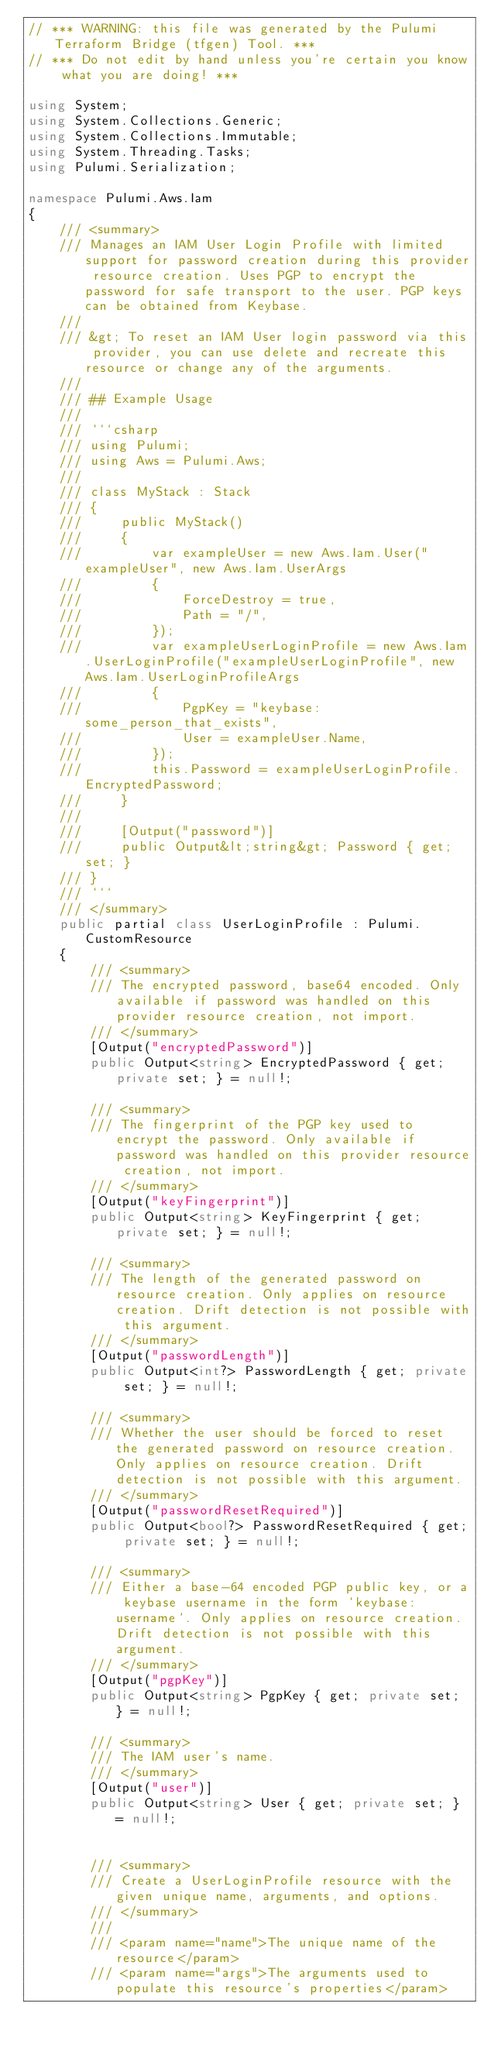<code> <loc_0><loc_0><loc_500><loc_500><_C#_>// *** WARNING: this file was generated by the Pulumi Terraform Bridge (tfgen) Tool. ***
// *** Do not edit by hand unless you're certain you know what you are doing! ***

using System;
using System.Collections.Generic;
using System.Collections.Immutable;
using System.Threading.Tasks;
using Pulumi.Serialization;

namespace Pulumi.Aws.Iam
{
    /// <summary>
    /// Manages an IAM User Login Profile with limited support for password creation during this provider resource creation. Uses PGP to encrypt the password for safe transport to the user. PGP keys can be obtained from Keybase.
    /// 
    /// &gt; To reset an IAM User login password via this provider, you can use delete and recreate this resource or change any of the arguments.
    /// 
    /// ## Example Usage
    /// 
    /// ```csharp
    /// using Pulumi;
    /// using Aws = Pulumi.Aws;
    /// 
    /// class MyStack : Stack
    /// {
    ///     public MyStack()
    ///     {
    ///         var exampleUser = new Aws.Iam.User("exampleUser", new Aws.Iam.UserArgs
    ///         {
    ///             ForceDestroy = true,
    ///             Path = "/",
    ///         });
    ///         var exampleUserLoginProfile = new Aws.Iam.UserLoginProfile("exampleUserLoginProfile", new Aws.Iam.UserLoginProfileArgs
    ///         {
    ///             PgpKey = "keybase:some_person_that_exists",
    ///             User = exampleUser.Name,
    ///         });
    ///         this.Password = exampleUserLoginProfile.EncryptedPassword;
    ///     }
    /// 
    ///     [Output("password")]
    ///     public Output&lt;string&gt; Password { get; set; }
    /// }
    /// ```
    /// </summary>
    public partial class UserLoginProfile : Pulumi.CustomResource
    {
        /// <summary>
        /// The encrypted password, base64 encoded. Only available if password was handled on this provider resource creation, not import.
        /// </summary>
        [Output("encryptedPassword")]
        public Output<string> EncryptedPassword { get; private set; } = null!;

        /// <summary>
        /// The fingerprint of the PGP key used to encrypt the password. Only available if password was handled on this provider resource creation, not import.
        /// </summary>
        [Output("keyFingerprint")]
        public Output<string> KeyFingerprint { get; private set; } = null!;

        /// <summary>
        /// The length of the generated password on resource creation. Only applies on resource creation. Drift detection is not possible with this argument.
        /// </summary>
        [Output("passwordLength")]
        public Output<int?> PasswordLength { get; private set; } = null!;

        /// <summary>
        /// Whether the user should be forced to reset the generated password on resource creation. Only applies on resource creation. Drift detection is not possible with this argument.
        /// </summary>
        [Output("passwordResetRequired")]
        public Output<bool?> PasswordResetRequired { get; private set; } = null!;

        /// <summary>
        /// Either a base-64 encoded PGP public key, or a keybase username in the form `keybase:username`. Only applies on resource creation. Drift detection is not possible with this argument.
        /// </summary>
        [Output("pgpKey")]
        public Output<string> PgpKey { get; private set; } = null!;

        /// <summary>
        /// The IAM user's name.
        /// </summary>
        [Output("user")]
        public Output<string> User { get; private set; } = null!;


        /// <summary>
        /// Create a UserLoginProfile resource with the given unique name, arguments, and options.
        /// </summary>
        ///
        /// <param name="name">The unique name of the resource</param>
        /// <param name="args">The arguments used to populate this resource's properties</param></code> 